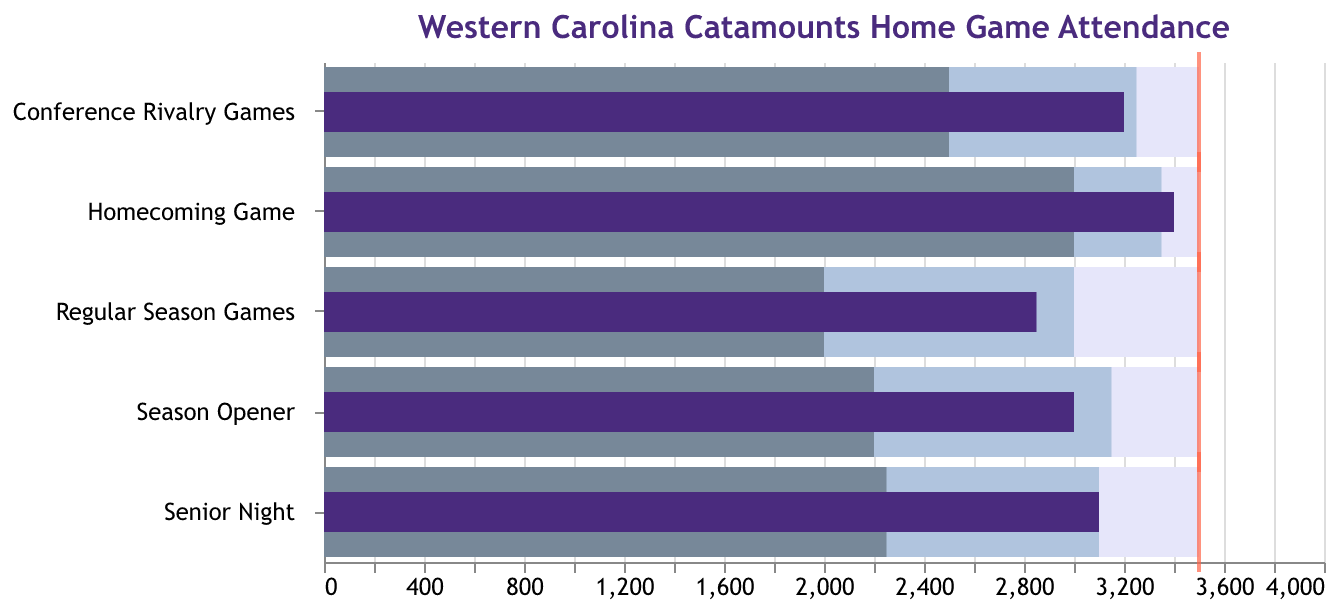What is the title of the figure? The title of the figure is clearly displayed at the top.
Answer: Western Carolina Catamounts Home Game Attendance Which game had the highest actual attendance? We look for the highest value in the "Actual" attendance bars. "Homecoming Game" has the tallest bar.
Answer: Homecoming Game Which game had the lowest actual attendance? We look for the lowest value in the "Actual" attendance bars. "Regular Season Games" has the shortest bar.
Answer: Regular Season Games Is there any game where the actual attendance met the target attendance? We compare the actual attendance bars with the target ticks (in red). None of the actual attendance bars reach the target ticks.
Answer: No What is the difference between actual and target attendance for the Season Opener? The actual attendance for Season Opener is 3000, and the target is 3500. The difference is calculated as 3500 - 3000.
Answer: 500 Which game came closest to meeting the target attendance? To determine this, we look for the smallest difference between the target tick and the actual attendance bar. "Homecoming Game" has an actual of 3400 and target of 3500, a difference of 100.
Answer: Homecoming Game What is the median actual attendance across all games? The actual attendance values are 2850, 3200, 3400, 3100, and 3000. When sorted, they are: 2850, 3000, 3100, 3200, 3400. The median is the middle value.
Answer: 3100 How does the actual attendance for Senior Night compare with that for Conference Rivalry Games? Senior Night has an actual attendance of 3100, while Conference Rivalry Games have 3200. Comparing these two, 3100 < 3200.
Answer: Less than What is the range of attendance for Regular Season Games? The range is given from Range1 to Range3 values. For Regular Season Games, it is from 2000 to 3500.
Answer: 2000 to 3500 How many games fall within their second range? We need to check which games' actual attendance falls within their Range2 values. Conference Rivalry Games (2500 to 3250) and Senior Night (2250 to 3100) fall within these ranges.
Answer: 2 